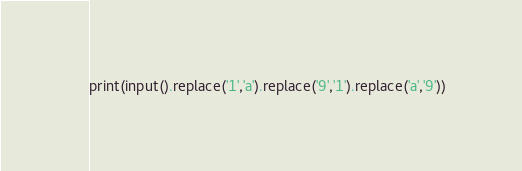Convert code to text. <code><loc_0><loc_0><loc_500><loc_500><_Python_>print(input().replace('1','a').replace('9','1').replace('a','9'))
</code> 